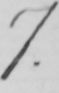Can you tell me what this handwritten text says? 7 . 